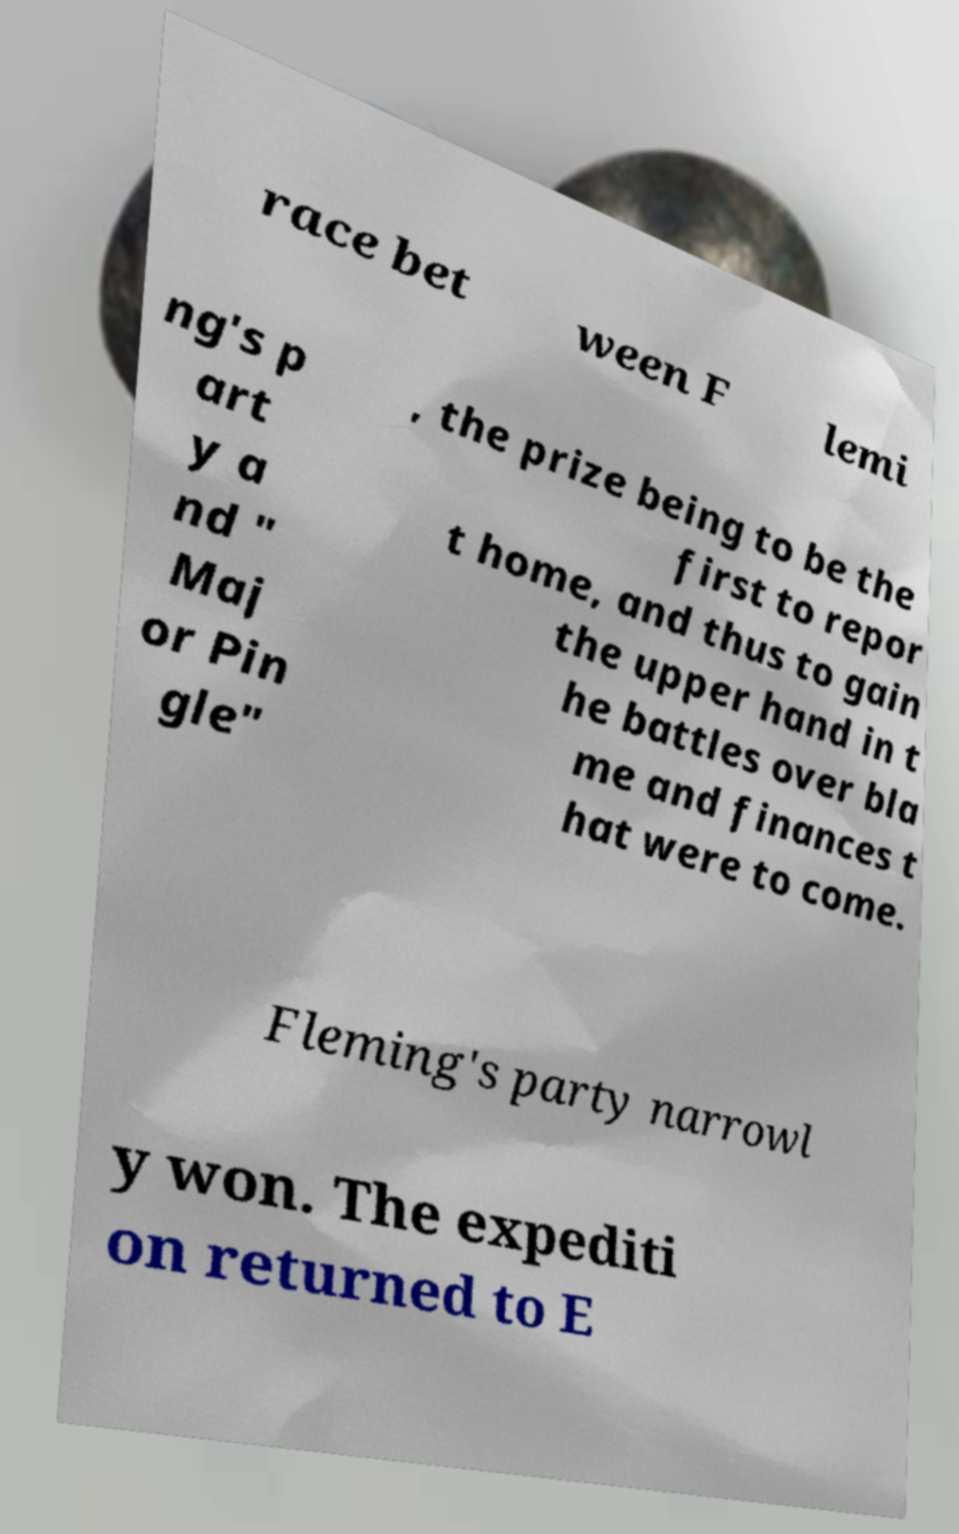Could you extract and type out the text from this image? race bet ween F lemi ng's p art y a nd " Maj or Pin gle" , the prize being to be the first to repor t home, and thus to gain the upper hand in t he battles over bla me and finances t hat were to come. Fleming's party narrowl y won. The expediti on returned to E 